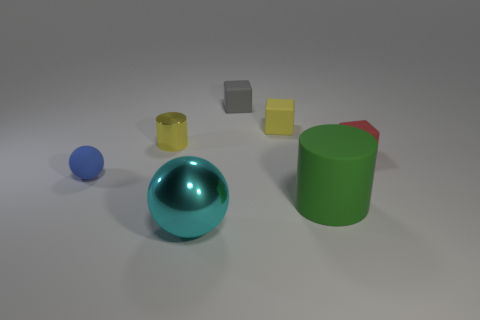Are there any matte things to the left of the green object?
Give a very brief answer. Yes. What shape is the big metal object?
Your answer should be compact. Sphere. What number of objects are either spheres that are in front of the tiny sphere or small matte cylinders?
Ensure brevity in your answer.  1. How many other objects are there of the same color as the tiny metal cylinder?
Your response must be concise. 1. There is a metallic object that is the same shape as the blue matte thing; what is its color?
Offer a very short reply. Cyan. Are the small sphere and the cylinder that is in front of the small shiny cylinder made of the same material?
Provide a succinct answer. Yes. What color is the big metallic ball?
Your answer should be compact. Cyan. What is the color of the cube that is in front of the tiny yellow object on the left side of the big metallic object in front of the small blue ball?
Give a very brief answer. Red. Does the gray object have the same shape as the small rubber thing right of the green rubber thing?
Your answer should be compact. Yes. What color is the block that is behind the yellow cylinder and to the right of the gray cube?
Offer a very short reply. Yellow. 